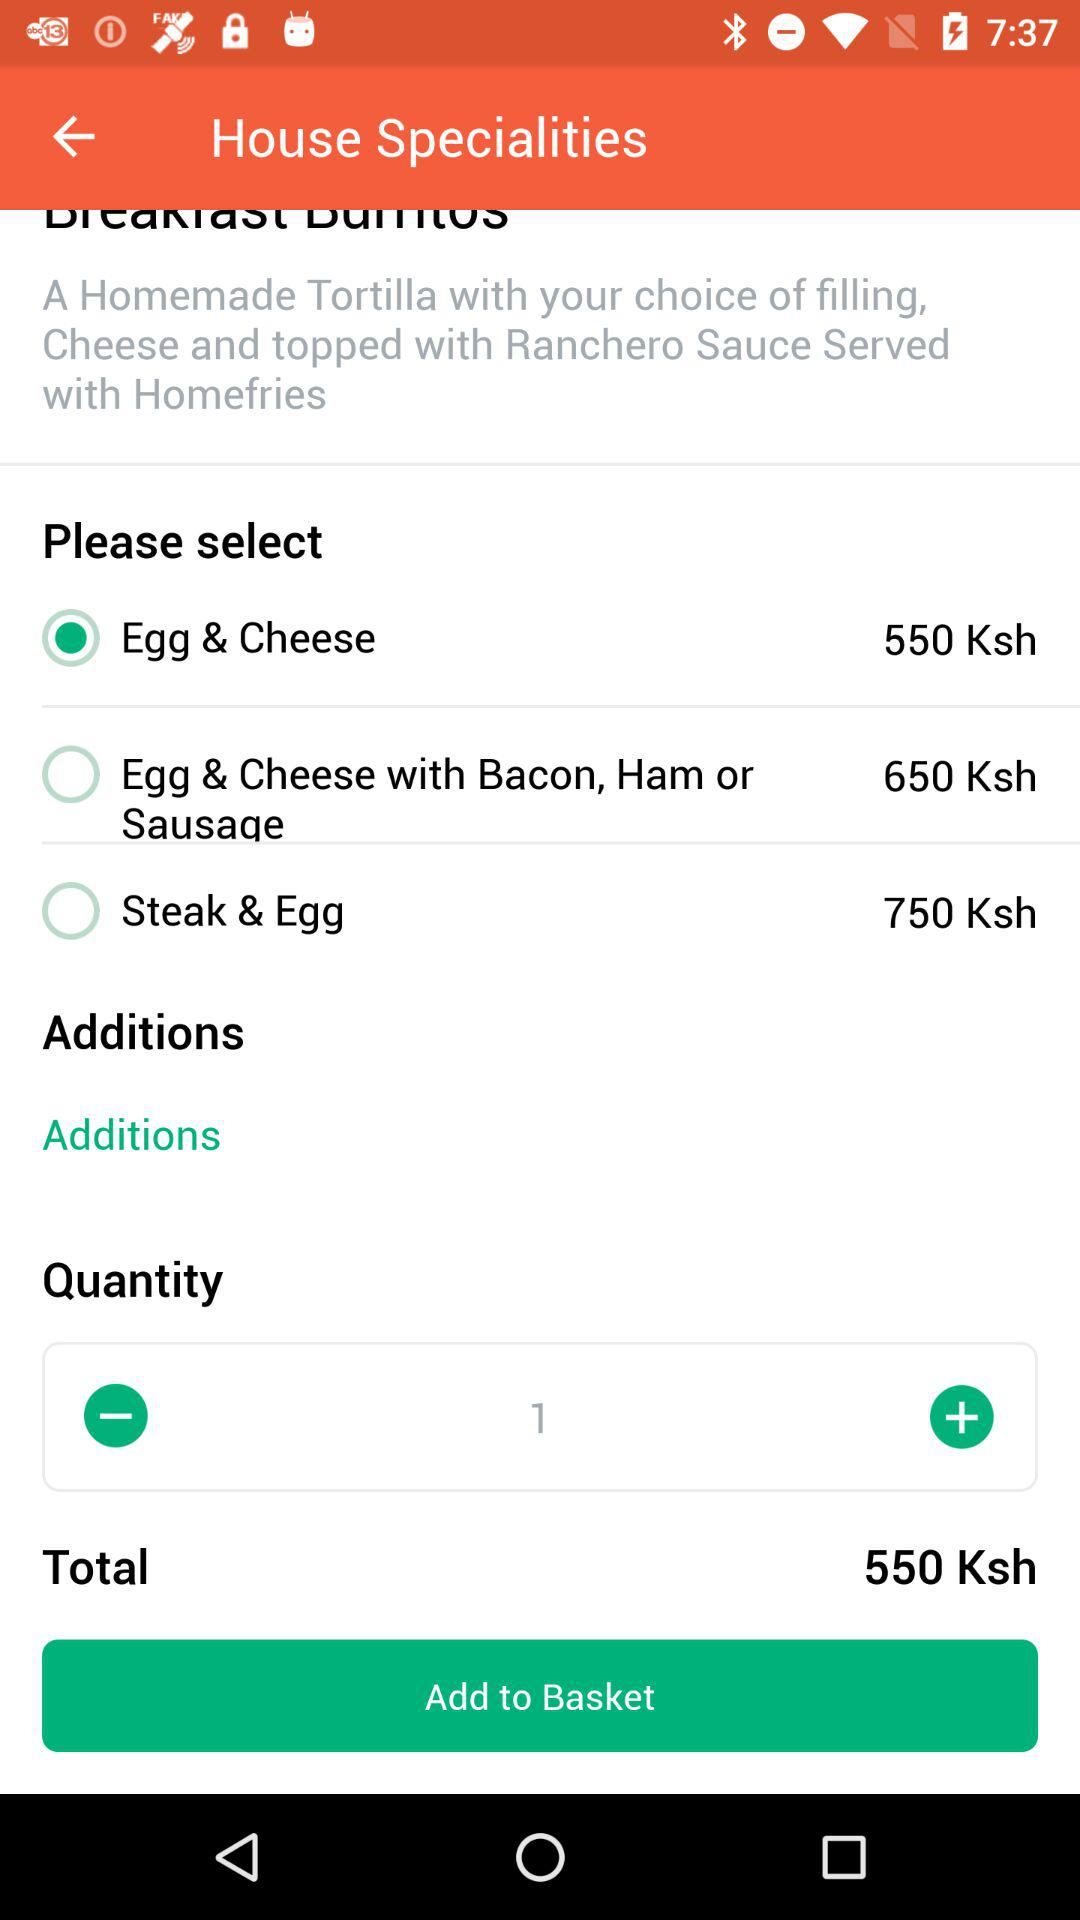What is the total price of the selected item?
Answer the question using a single word or phrase. 550 Ksh 